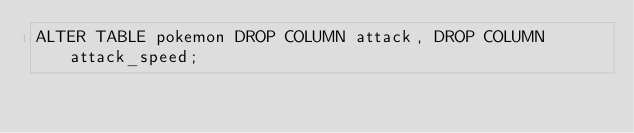Convert code to text. <code><loc_0><loc_0><loc_500><loc_500><_SQL_>ALTER TABLE pokemon DROP COLUMN attack, DROP COLUMN attack_speed;
</code> 